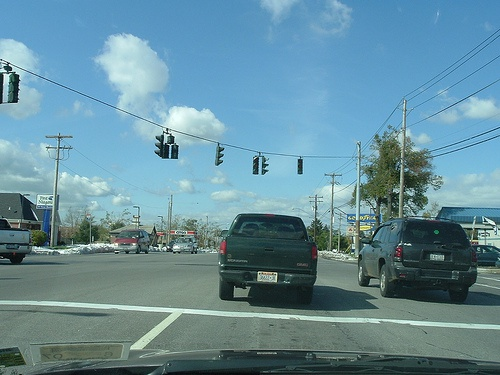Describe the objects in this image and their specific colors. I can see car in lightblue, black, and teal tones, truck in lightblue, black, and teal tones, truck in lightblue, black, teal, and purple tones, car in lightblue, gray, teal, black, and darkgray tones, and traffic light in lightblue, black, and teal tones in this image. 